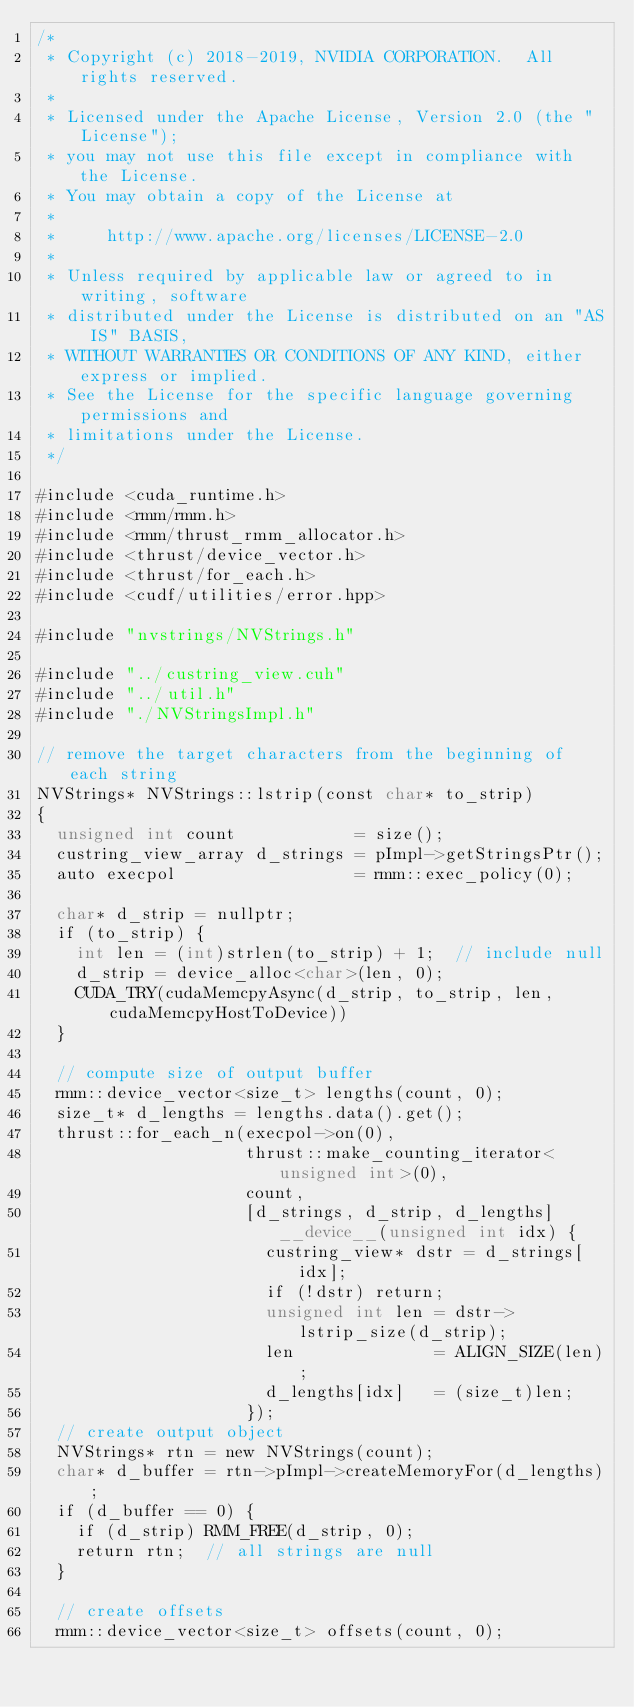Convert code to text. <code><loc_0><loc_0><loc_500><loc_500><_Cuda_>/*
 * Copyright (c) 2018-2019, NVIDIA CORPORATION.  All rights reserved.
 *
 * Licensed under the Apache License, Version 2.0 (the "License");
 * you may not use this file except in compliance with the License.
 * You may obtain a copy of the License at
 *
 *     http://www.apache.org/licenses/LICENSE-2.0
 *
 * Unless required by applicable law or agreed to in writing, software
 * distributed under the License is distributed on an "AS IS" BASIS,
 * WITHOUT WARRANTIES OR CONDITIONS OF ANY KIND, either express or implied.
 * See the License for the specific language governing permissions and
 * limitations under the License.
 */

#include <cuda_runtime.h>
#include <rmm/rmm.h>
#include <rmm/thrust_rmm_allocator.h>
#include <thrust/device_vector.h>
#include <thrust/for_each.h>
#include <cudf/utilities/error.hpp>

#include "nvstrings/NVStrings.h"

#include "../custring_view.cuh"
#include "../util.h"
#include "./NVStringsImpl.h"

// remove the target characters from the beginning of each string
NVStrings* NVStrings::lstrip(const char* to_strip)
{
  unsigned int count            = size();
  custring_view_array d_strings = pImpl->getStringsPtr();
  auto execpol                  = rmm::exec_policy(0);

  char* d_strip = nullptr;
  if (to_strip) {
    int len = (int)strlen(to_strip) + 1;  // include null
    d_strip = device_alloc<char>(len, 0);
    CUDA_TRY(cudaMemcpyAsync(d_strip, to_strip, len, cudaMemcpyHostToDevice))
  }

  // compute size of output buffer
  rmm::device_vector<size_t> lengths(count, 0);
  size_t* d_lengths = lengths.data().get();
  thrust::for_each_n(execpol->on(0),
                     thrust::make_counting_iterator<unsigned int>(0),
                     count,
                     [d_strings, d_strip, d_lengths] __device__(unsigned int idx) {
                       custring_view* dstr = d_strings[idx];
                       if (!dstr) return;
                       unsigned int len = dstr->lstrip_size(d_strip);
                       len              = ALIGN_SIZE(len);
                       d_lengths[idx]   = (size_t)len;
                     });
  // create output object
  NVStrings* rtn = new NVStrings(count);
  char* d_buffer = rtn->pImpl->createMemoryFor(d_lengths);
  if (d_buffer == 0) {
    if (d_strip) RMM_FREE(d_strip, 0);
    return rtn;  // all strings are null
  }

  // create offsets
  rmm::device_vector<size_t> offsets(count, 0);</code> 